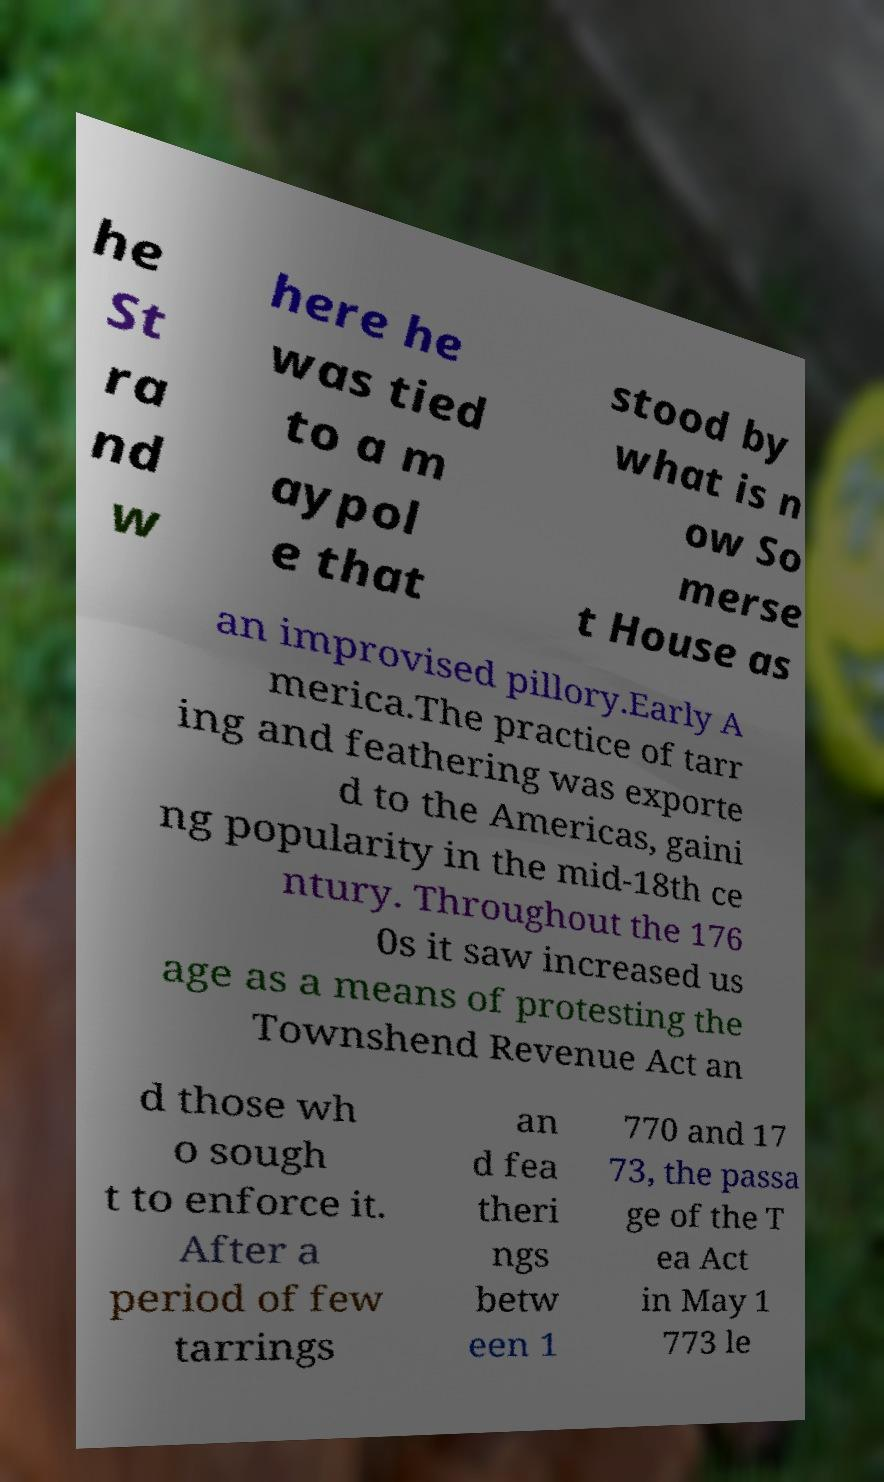Can you accurately transcribe the text from the provided image for me? he St ra nd w here he was tied to a m aypol e that stood by what is n ow So merse t House as an improvised pillory.Early A merica.The practice of tarr ing and feathering was exporte d to the Americas, gaini ng popularity in the mid-18th ce ntury. Throughout the 176 0s it saw increased us age as a means of protesting the Townshend Revenue Act an d those wh o sough t to enforce it. After a period of few tarrings an d fea theri ngs betw een 1 770 and 17 73, the passa ge of the T ea Act in May 1 773 le 